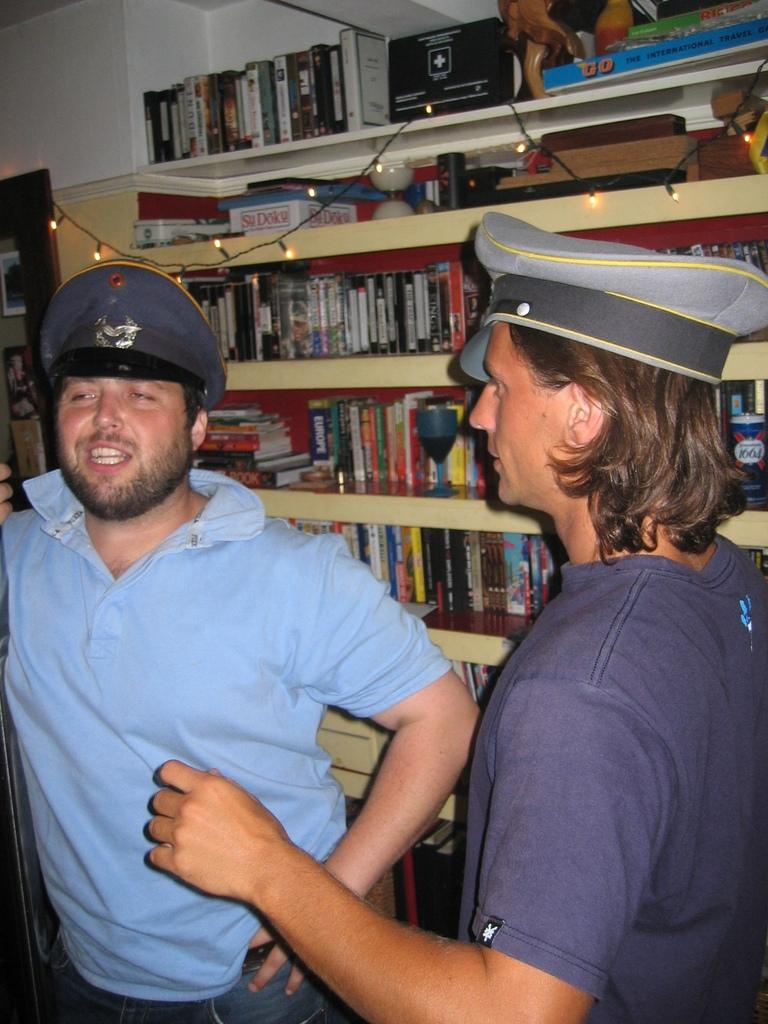How many people are in the image? There are two persons in the image. What are the persons wearing on their heads? The persons are wearing caps. What can be seen on the racks in the image? There are books, boxes, and other objects on the racks. Are there any decorative elements in the image? Yes, there are serial lights in the image. What type of structure can be seen in the image? There are walls visible in the image. Can you hear the sound of a gunshot in the image? There is no mention of a gun or gunshot in the image, so it cannot be heard. 